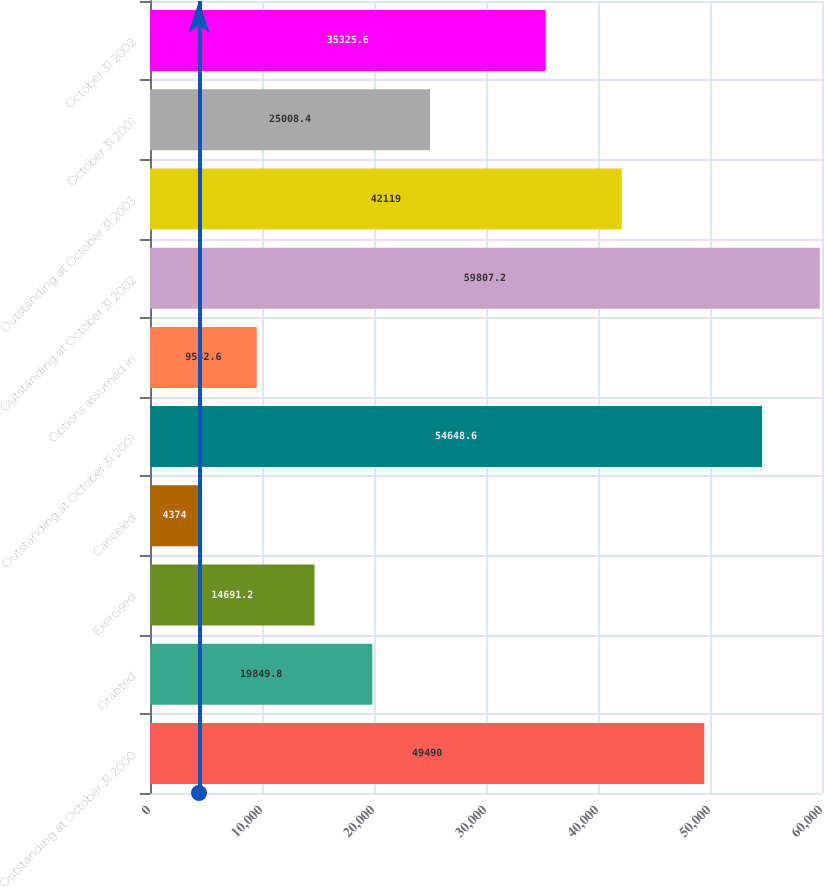<chart> <loc_0><loc_0><loc_500><loc_500><bar_chart><fcel>Outstanding at October 31 2000<fcel>Granted<fcel>Exercised<fcel>Canceled<fcel>Outstanding at October 31 2001<fcel>Options assumed in<fcel>Outstanding at October 31 2002<fcel>Outstanding at October 31 2003<fcel>October 31 2001<fcel>October 31 2002<nl><fcel>49490<fcel>19849.8<fcel>14691.2<fcel>4374<fcel>54648.6<fcel>9532.6<fcel>59807.2<fcel>42119<fcel>25008.4<fcel>35325.6<nl></chart> 